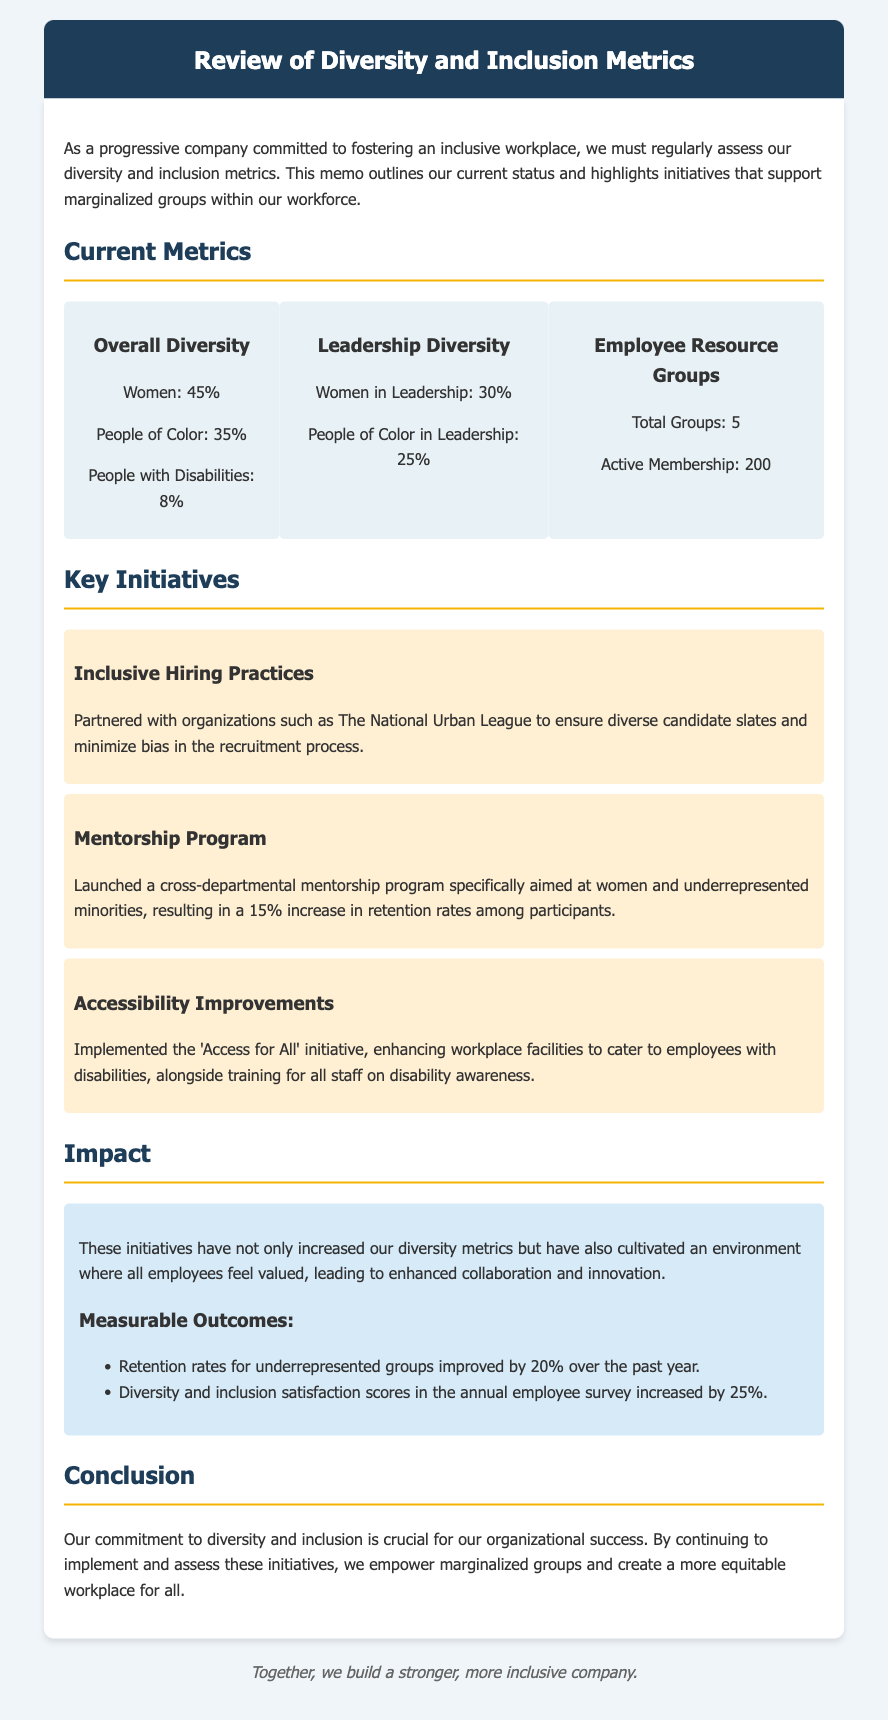What is the percentage of women in the workforce? The document states that the percentage of women in the workforce is 45%.
Answer: 45% What percentage of people of color are in leadership? According to the document, people of color in leadership make up 25%.
Answer: 25% How many total employee resource groups are there? The document mentions that there are a total of 5 employee resource groups.
Answer: 5 What initiative aims to enhance facilities for employees with disabilities? The initiative mentioned in the document is called 'Access for All'.
Answer: Access for All What was the retention rate increase for participants in the mentorship program? The document states that there was a 15% increase in retention rates among participants.
Answer: 15% What are the diversity and inclusion satisfaction scores' increase percentage in the annual survey? The document notes that the satisfaction scores increased by 25%.
Answer: 25% How many active members are in the employee resource groups? The document specifies there are 200 active members in the employee resource groups.
Answer: 200 Which organization did the company partner with for inclusive hiring practices? The document states the company partnered with The National Urban League.
Answer: The National Urban League What is the overall percentage of people with disabilities in the workforce? The percentage of people with disabilities in the workforce is 8%.
Answer: 8% 